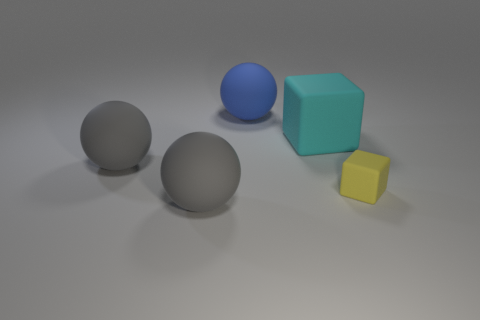Is there a tiny block of the same color as the large matte block?
Your response must be concise. No. Is there any other thing that has the same size as the blue rubber thing?
Provide a short and direct response. Yes. How many big things are the same color as the small cube?
Give a very brief answer. 0. Is the color of the tiny matte cube the same as the cube on the left side of the tiny yellow object?
Give a very brief answer. No. What number of objects are rubber blocks or rubber objects that are left of the large matte block?
Your response must be concise. 5. What size is the sphere left of the gray sphere that is in front of the small cube?
Your response must be concise. Large. Are there an equal number of big gray things that are to the right of the large block and yellow matte objects that are in front of the big blue matte thing?
Make the answer very short. No. Are there any balls that are to the right of the large matte thing that is to the right of the big blue matte object?
Your answer should be compact. No. There is a tiny thing that is the same material as the cyan block; what shape is it?
Provide a short and direct response. Cube. Are there any other things that are the same color as the small rubber block?
Offer a very short reply. No. 